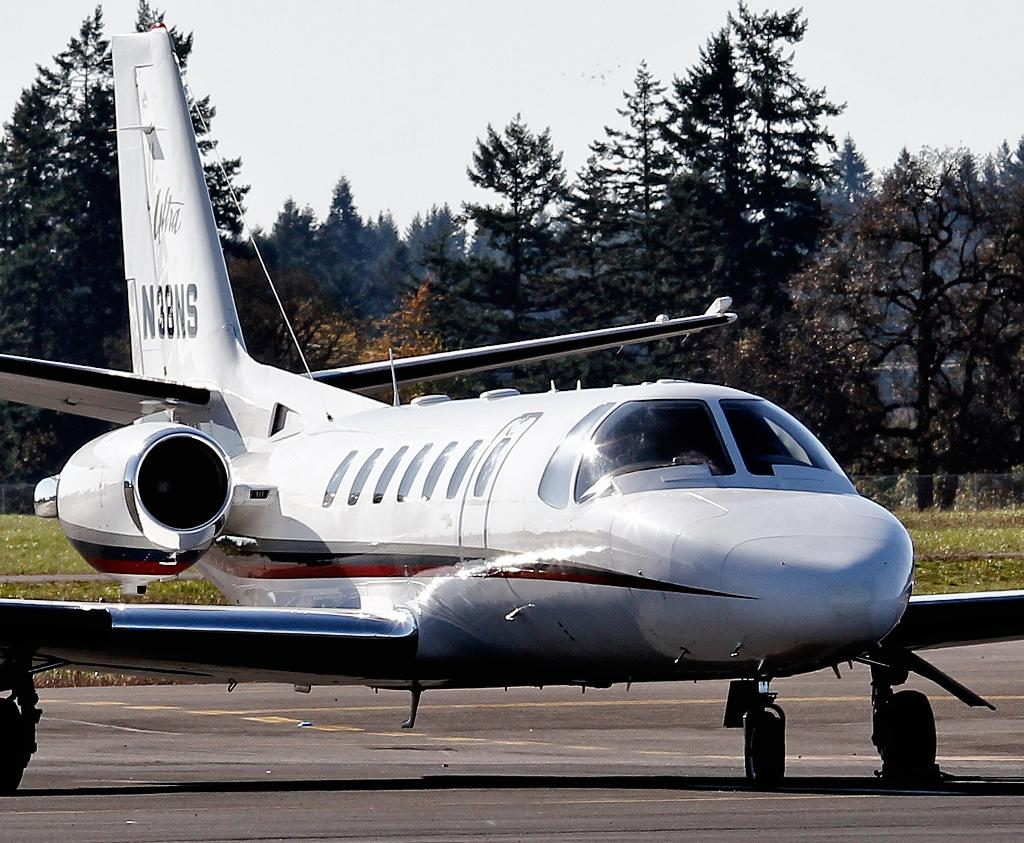<image>
Offer a succinct explanation of the picture presented. a plane parked on a runway with N3BNS on the tail 